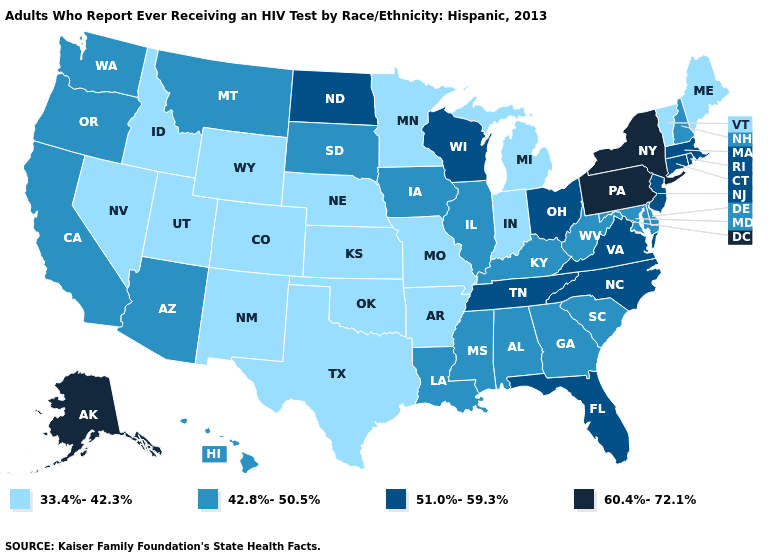How many symbols are there in the legend?
Answer briefly. 4. What is the highest value in states that border Arkansas?
Quick response, please. 51.0%-59.3%. Name the states that have a value in the range 60.4%-72.1%?
Short answer required. Alaska, New York, Pennsylvania. Does Michigan have the highest value in the MidWest?
Short answer required. No. Which states have the lowest value in the South?
Quick response, please. Arkansas, Oklahoma, Texas. What is the lowest value in states that border Washington?
Give a very brief answer. 33.4%-42.3%. What is the lowest value in the Northeast?
Quick response, please. 33.4%-42.3%. What is the value of New Hampshire?
Keep it brief. 42.8%-50.5%. What is the value of New Jersey?
Concise answer only. 51.0%-59.3%. Which states have the highest value in the USA?
Quick response, please. Alaska, New York, Pennsylvania. Does North Carolina have a lower value than Alaska?
Write a very short answer. Yes. Name the states that have a value in the range 60.4%-72.1%?
Short answer required. Alaska, New York, Pennsylvania. Does the first symbol in the legend represent the smallest category?
Keep it brief. Yes. What is the highest value in states that border New Hampshire?
Quick response, please. 51.0%-59.3%. What is the highest value in the South ?
Write a very short answer. 51.0%-59.3%. 